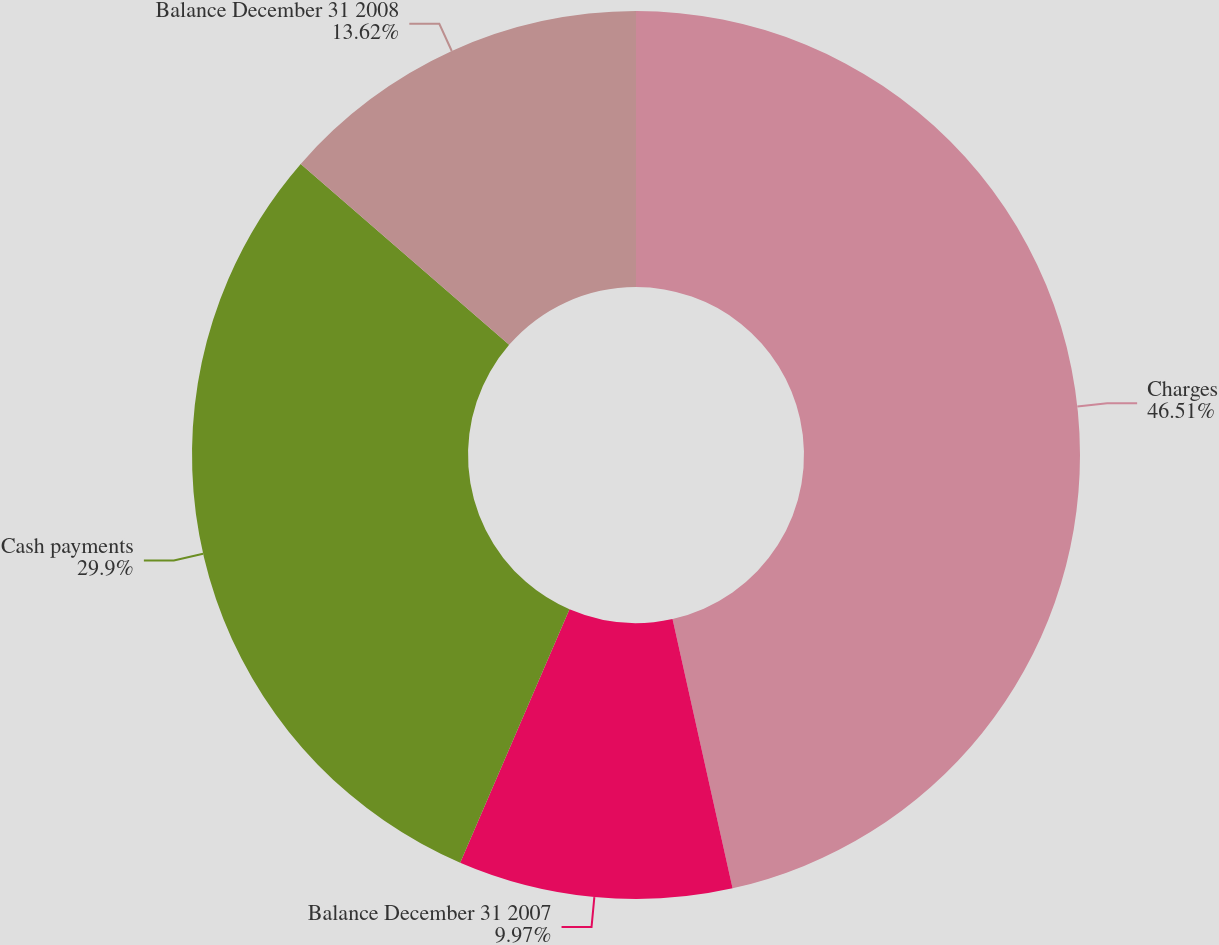Convert chart to OTSL. <chart><loc_0><loc_0><loc_500><loc_500><pie_chart><fcel>Charges<fcel>Balance December 31 2007<fcel>Cash payments<fcel>Balance December 31 2008<nl><fcel>46.51%<fcel>9.97%<fcel>29.9%<fcel>13.62%<nl></chart> 